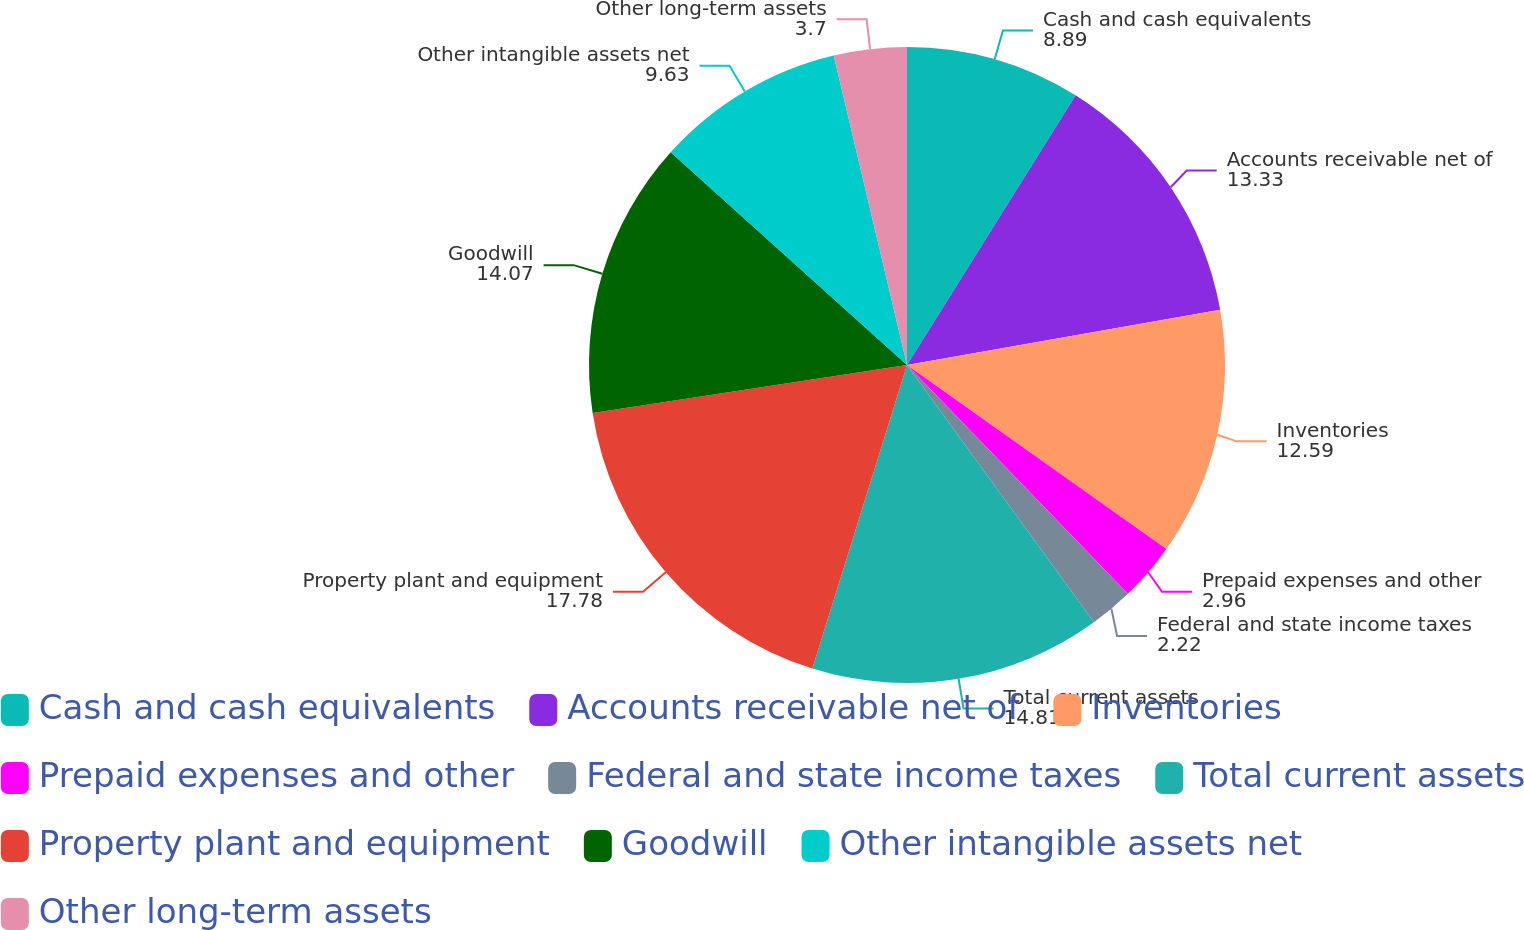Convert chart. <chart><loc_0><loc_0><loc_500><loc_500><pie_chart><fcel>Cash and cash equivalents<fcel>Accounts receivable net of<fcel>Inventories<fcel>Prepaid expenses and other<fcel>Federal and state income taxes<fcel>Total current assets<fcel>Property plant and equipment<fcel>Goodwill<fcel>Other intangible assets net<fcel>Other long-term assets<nl><fcel>8.89%<fcel>13.33%<fcel>12.59%<fcel>2.96%<fcel>2.22%<fcel>14.81%<fcel>17.78%<fcel>14.07%<fcel>9.63%<fcel>3.7%<nl></chart> 